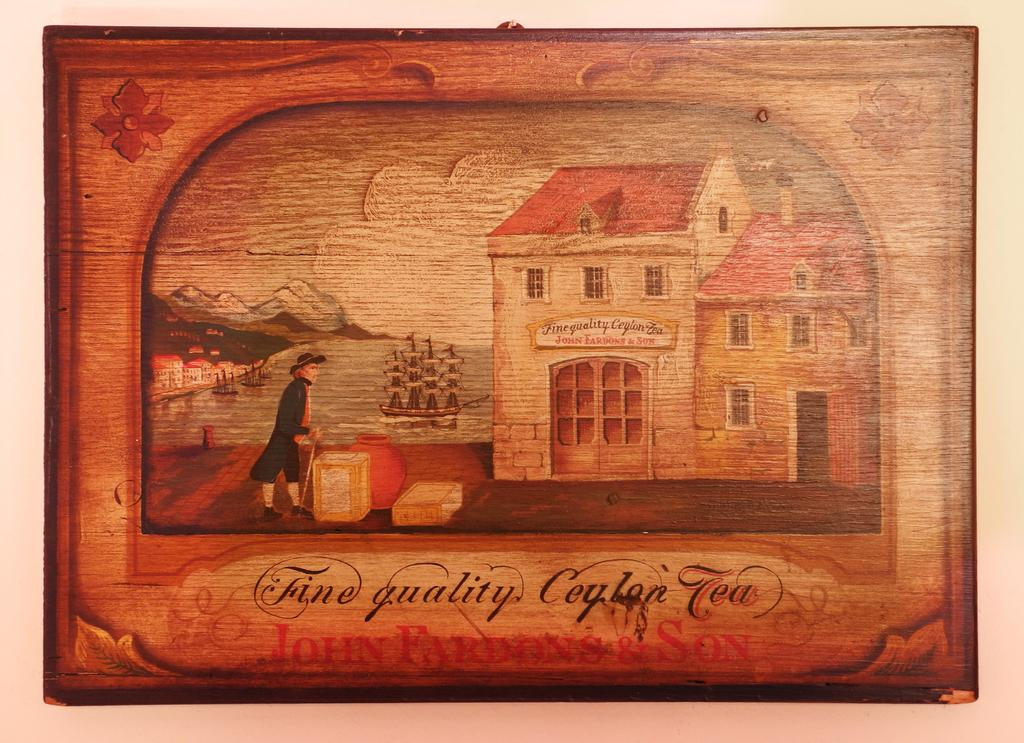<image>
Write a terse but informative summary of the picture. A painting that reads fine quality coylon tea. 